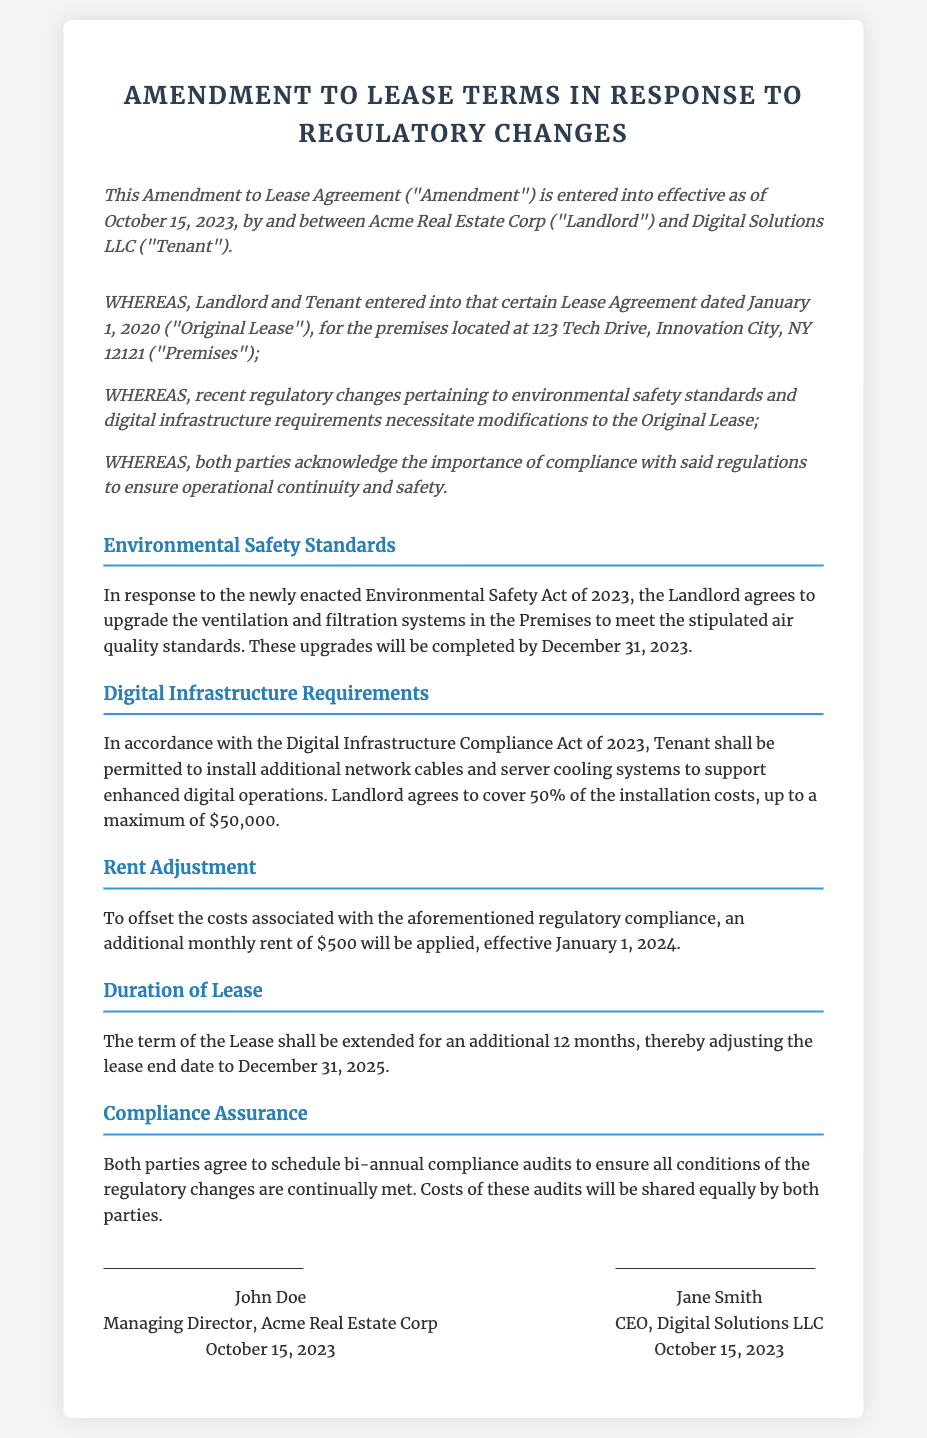What is the effective date of the amendment? The amendment is entered into effective as of October 15, 2023.
Answer: October 15, 2023 What is the name of the landlord? The landlord's name is Acme Real Estate Corp.
Answer: Acme Real Estate Corp What environmental regulations prompted the amendments? The amendments are in response to the newly enacted Environmental Safety Act of 2023.
Answer: Environmental Safety Act of 2023 How much will the landlord contribute to digital infrastructure installation? The landlord agrees to cover 50% of the installation costs, up to a maximum of $50,000.
Answer: $50,000 When will the additional rent take effect? The additional rent of $500 will be applied effective January 1, 2024.
Answer: January 1, 2024 How long will the lease be extended? The lease shall be extended for an additional 12 months.
Answer: 12 months What will be scheduled bi-annually to ensure compliance? Both parties agree to schedule bi-annual compliance audits.
Answer: Compliance audits Who is the CEO of Digital Solutions LLC? The CEO is Jane Smith.
Answer: Jane Smith What is the new lease end date? The new lease end date is December 31, 2025.
Answer: December 31, 2025 